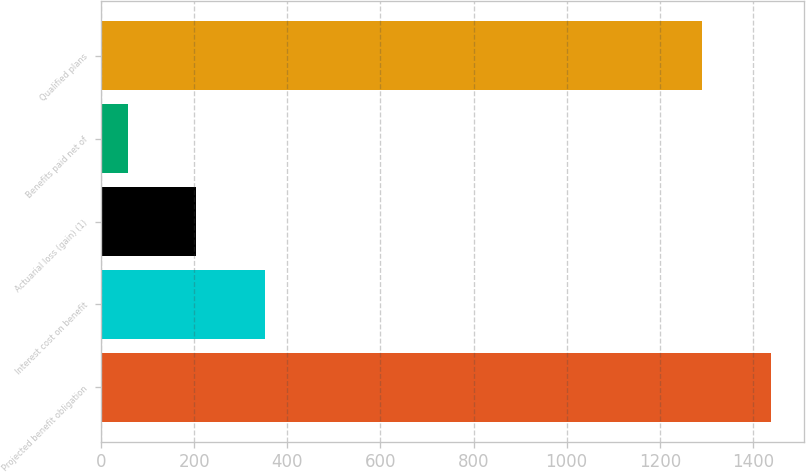<chart> <loc_0><loc_0><loc_500><loc_500><bar_chart><fcel>Projected benefit obligation<fcel>Interest cost on benefit<fcel>Actuarial loss (gain) (1)<fcel>Benefits paid net of<fcel>Qualified plans<nl><fcel>1438<fcel>351<fcel>204<fcel>57<fcel>1291<nl></chart> 